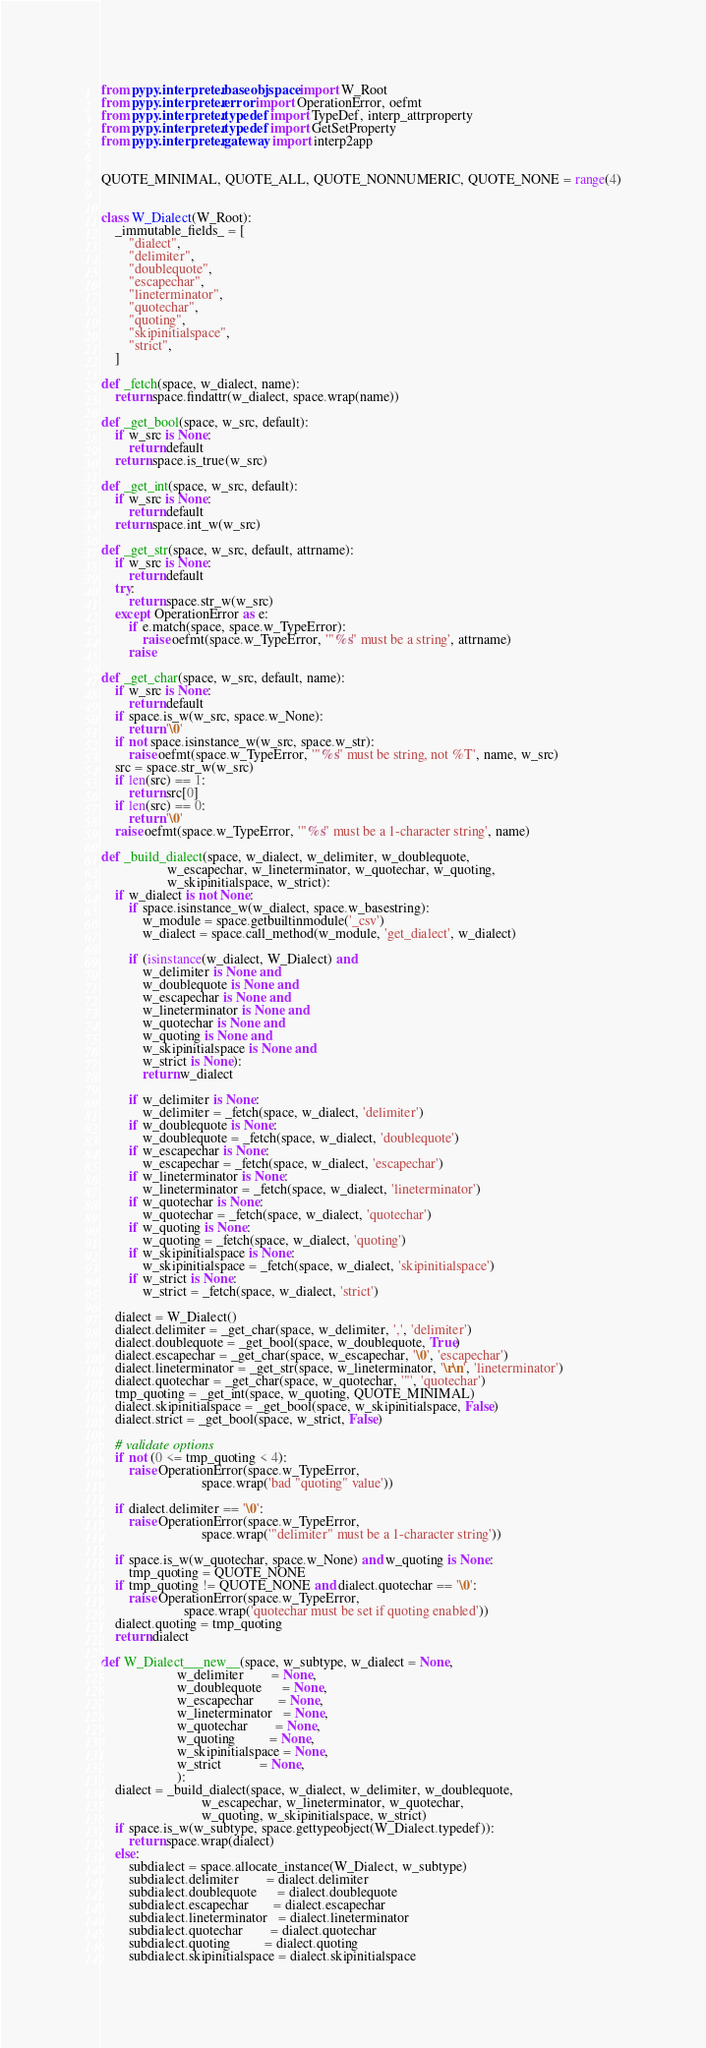Convert code to text. <code><loc_0><loc_0><loc_500><loc_500><_Python_>from pypy.interpreter.baseobjspace import W_Root
from pypy.interpreter.error import OperationError, oefmt
from pypy.interpreter.typedef import TypeDef, interp_attrproperty
from pypy.interpreter.typedef import GetSetProperty
from pypy.interpreter.gateway import interp2app


QUOTE_MINIMAL, QUOTE_ALL, QUOTE_NONNUMERIC, QUOTE_NONE = range(4)


class W_Dialect(W_Root):
    _immutable_fields_ = [
        "dialect",
        "delimiter",
        "doublequote",
        "escapechar",
        "lineterminator",
        "quotechar",
        "quoting",
        "skipinitialspace",
        "strict",
    ]

def _fetch(space, w_dialect, name):
    return space.findattr(w_dialect, space.wrap(name))

def _get_bool(space, w_src, default):
    if w_src is None:
        return default
    return space.is_true(w_src)

def _get_int(space, w_src, default):
    if w_src is None:
        return default
    return space.int_w(w_src)

def _get_str(space, w_src, default, attrname):
    if w_src is None:
        return default
    try:
        return space.str_w(w_src)
    except OperationError as e:
        if e.match(space, space.w_TypeError):
            raise oefmt(space.w_TypeError, '"%s" must be a string', attrname)
        raise

def _get_char(space, w_src, default, name):
    if w_src is None:
        return default
    if space.is_w(w_src, space.w_None):
        return '\0'
    if not space.isinstance_w(w_src, space.w_str):
        raise oefmt(space.w_TypeError, '"%s" must be string, not %T', name, w_src)
    src = space.str_w(w_src)
    if len(src) == 1:
        return src[0]
    if len(src) == 0:
        return '\0'
    raise oefmt(space.w_TypeError, '"%s" must be a 1-character string', name)

def _build_dialect(space, w_dialect, w_delimiter, w_doublequote,
                   w_escapechar, w_lineterminator, w_quotechar, w_quoting,
                   w_skipinitialspace, w_strict):
    if w_dialect is not None:
        if space.isinstance_w(w_dialect, space.w_basestring):
            w_module = space.getbuiltinmodule('_csv')
            w_dialect = space.call_method(w_module, 'get_dialect', w_dialect)

        if (isinstance(w_dialect, W_Dialect) and
            w_delimiter is None and
            w_doublequote is None and
            w_escapechar is None and
            w_lineterminator is None and
            w_quotechar is None and
            w_quoting is None and
            w_skipinitialspace is None and
            w_strict is None):
            return w_dialect

        if w_delimiter is None:
            w_delimiter = _fetch(space, w_dialect, 'delimiter')
        if w_doublequote is None:
            w_doublequote = _fetch(space, w_dialect, 'doublequote')
        if w_escapechar is None:
            w_escapechar = _fetch(space, w_dialect, 'escapechar')
        if w_lineterminator is None:
            w_lineterminator = _fetch(space, w_dialect, 'lineterminator')
        if w_quotechar is None:
            w_quotechar = _fetch(space, w_dialect, 'quotechar')
        if w_quoting is None:
            w_quoting = _fetch(space, w_dialect, 'quoting')
        if w_skipinitialspace is None:
            w_skipinitialspace = _fetch(space, w_dialect, 'skipinitialspace')
        if w_strict is None:
            w_strict = _fetch(space, w_dialect, 'strict')

    dialect = W_Dialect()
    dialect.delimiter = _get_char(space, w_delimiter, ',', 'delimiter')
    dialect.doublequote = _get_bool(space, w_doublequote, True)
    dialect.escapechar = _get_char(space, w_escapechar, '\0', 'escapechar')
    dialect.lineterminator = _get_str(space, w_lineterminator, '\r\n', 'lineterminator')
    dialect.quotechar = _get_char(space, w_quotechar, '"', 'quotechar')
    tmp_quoting = _get_int(space, w_quoting, QUOTE_MINIMAL)
    dialect.skipinitialspace = _get_bool(space, w_skipinitialspace, False)
    dialect.strict = _get_bool(space, w_strict, False)

    # validate options
    if not (0 <= tmp_quoting < 4):
        raise OperationError(space.w_TypeError,
                             space.wrap('bad "quoting" value'))

    if dialect.delimiter == '\0':
        raise OperationError(space.w_TypeError,
                             space.wrap('"delimiter" must be a 1-character string'))

    if space.is_w(w_quotechar, space.w_None) and w_quoting is None:
        tmp_quoting = QUOTE_NONE
    if tmp_quoting != QUOTE_NONE and dialect.quotechar == '\0':
        raise OperationError(space.w_TypeError,
                        space.wrap('quotechar must be set if quoting enabled'))
    dialect.quoting = tmp_quoting
    return dialect

def W_Dialect___new__(space, w_subtype, w_dialect = None,
                      w_delimiter        = None,
                      w_doublequote      = None,
                      w_escapechar       = None,
                      w_lineterminator   = None,
                      w_quotechar        = None,
                      w_quoting          = None,
                      w_skipinitialspace = None,
                      w_strict           = None,
                      ):
    dialect = _build_dialect(space, w_dialect, w_delimiter, w_doublequote,
                             w_escapechar, w_lineterminator, w_quotechar,
                             w_quoting, w_skipinitialspace, w_strict)
    if space.is_w(w_subtype, space.gettypeobject(W_Dialect.typedef)):
        return space.wrap(dialect)
    else:
        subdialect = space.allocate_instance(W_Dialect, w_subtype)
        subdialect.delimiter        = dialect.delimiter
        subdialect.doublequote      = dialect.doublequote
        subdialect.escapechar       = dialect.escapechar
        subdialect.lineterminator   = dialect.lineterminator
        subdialect.quotechar        = dialect.quotechar
        subdialect.quoting          = dialect.quoting
        subdialect.skipinitialspace = dialect.skipinitialspace</code> 